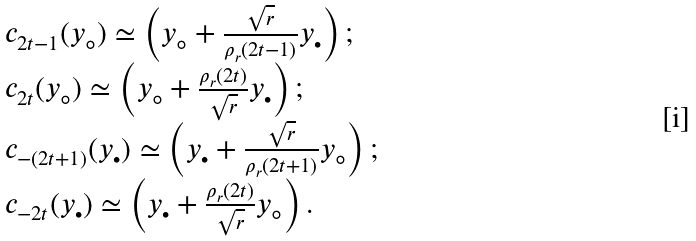<formula> <loc_0><loc_0><loc_500><loc_500>\begin{array} { l l l l } c _ { 2 t - 1 } ( y _ { \circ } ) \simeq \left ( y _ { \circ } + \frac { \sqrt { r } } { \rho _ { r } ( 2 t - 1 ) } y _ { \bullet } \right ) ; \\ c _ { 2 t } ( y _ { \circ } ) \simeq \left ( y _ { \circ } + \frac { \rho _ { r } ( 2 t ) } { \sqrt { r } } y _ { \bullet } \right ) ; \\ c _ { - ( 2 t + 1 ) } ( y _ { \bullet } ) \simeq \left ( y _ { \bullet } + \frac { \sqrt { r } } { \rho _ { r } ( 2 t + 1 ) } y _ { \circ } \right ) ; \\ c _ { - 2 t } ( y _ { \bullet } ) \simeq \left ( y _ { \bullet } + \frac { \rho _ { r } ( 2 t ) } { \sqrt { r } } y _ { \circ } \right ) . \\ \end{array}</formula> 